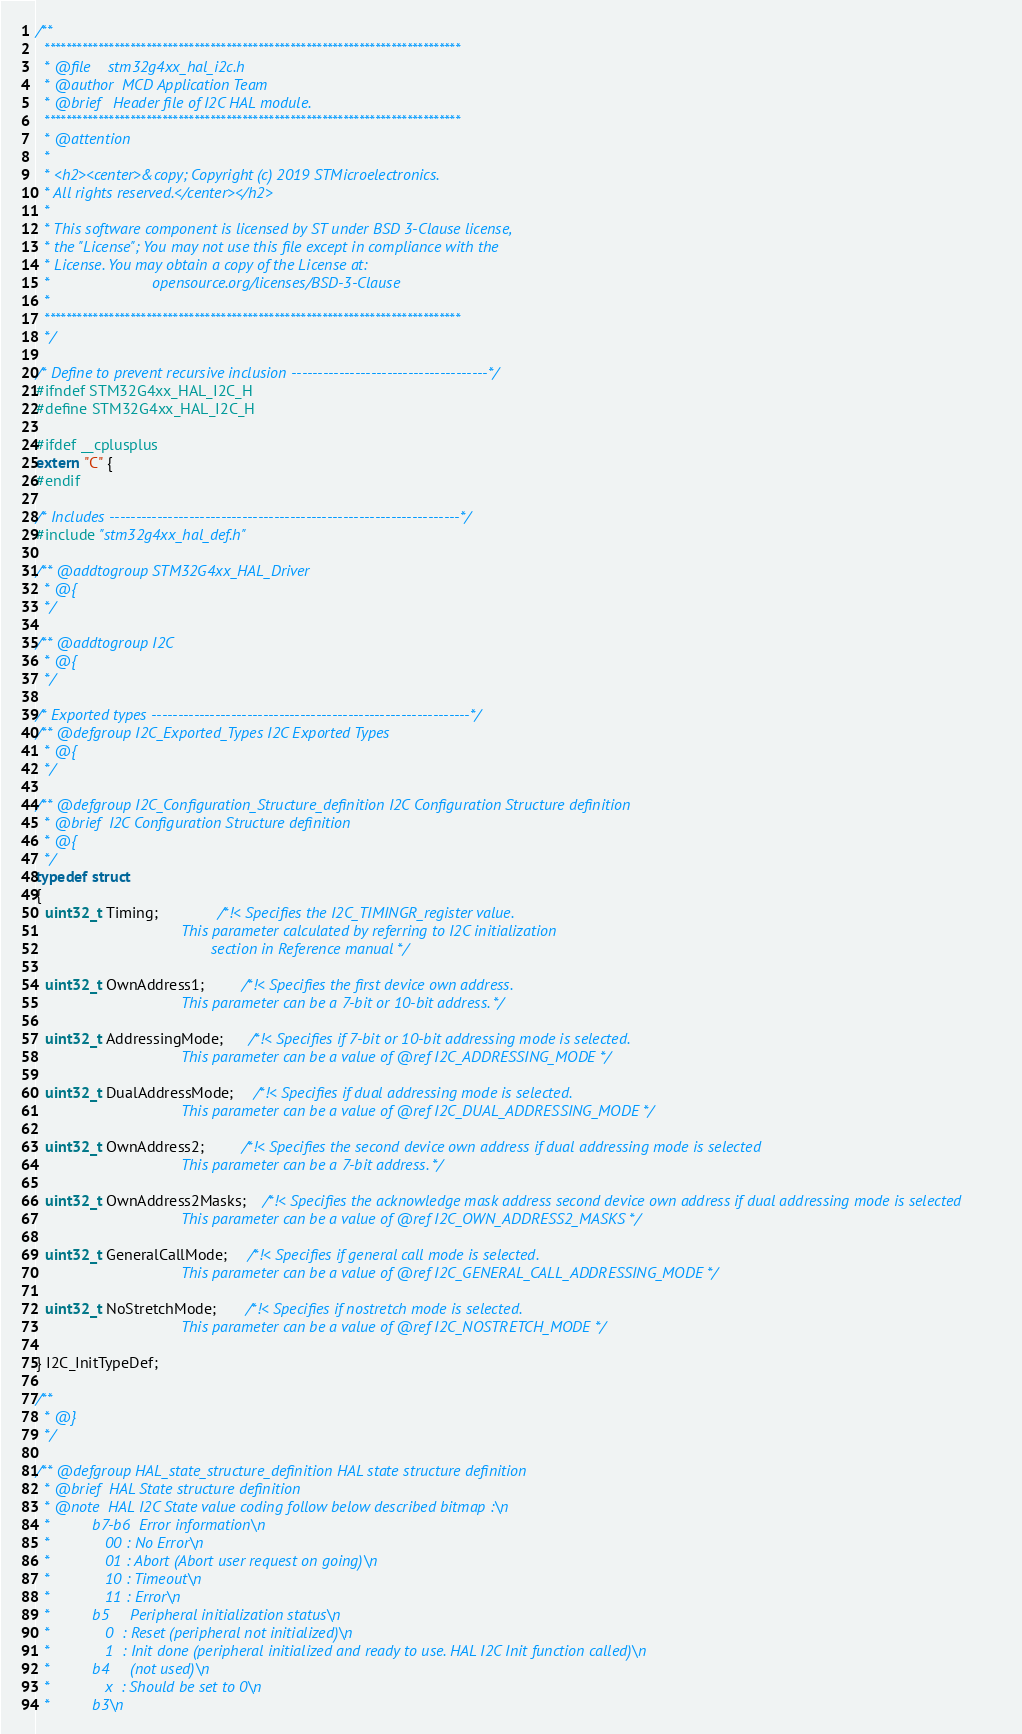<code> <loc_0><loc_0><loc_500><loc_500><_C_>/**
  ******************************************************************************
  * @file    stm32g4xx_hal_i2c.h
  * @author  MCD Application Team
  * @brief   Header file of I2C HAL module.
  ******************************************************************************
  * @attention
  *
  * <h2><center>&copy; Copyright (c) 2019 STMicroelectronics.
  * All rights reserved.</center></h2>
  *
  * This software component is licensed by ST under BSD 3-Clause license,
  * the "License"; You may not use this file except in compliance with the
  * License. You may obtain a copy of the License at:
  *                        opensource.org/licenses/BSD-3-Clause
  *
  ******************************************************************************
  */

/* Define to prevent recursive inclusion -------------------------------------*/
#ifndef STM32G4xx_HAL_I2C_H
#define STM32G4xx_HAL_I2C_H

#ifdef __cplusplus
extern "C" {
#endif

/* Includes ------------------------------------------------------------------*/
#include "stm32g4xx_hal_def.h"

/** @addtogroup STM32G4xx_HAL_Driver
  * @{
  */

/** @addtogroup I2C
  * @{
  */

/* Exported types ------------------------------------------------------------*/
/** @defgroup I2C_Exported_Types I2C Exported Types
  * @{
  */

/** @defgroup I2C_Configuration_Structure_definition I2C Configuration Structure definition
  * @brief  I2C Configuration Structure definition
  * @{
  */
typedef struct
{
  uint32_t Timing;              /*!< Specifies the I2C_TIMINGR_register value.
                                  This parameter calculated by referring to I2C initialization
                                         section in Reference manual */

  uint32_t OwnAddress1;         /*!< Specifies the first device own address.
                                  This parameter can be a 7-bit or 10-bit address. */

  uint32_t AddressingMode;      /*!< Specifies if 7-bit or 10-bit addressing mode is selected.
                                  This parameter can be a value of @ref I2C_ADDRESSING_MODE */

  uint32_t DualAddressMode;     /*!< Specifies if dual addressing mode is selected.
                                  This parameter can be a value of @ref I2C_DUAL_ADDRESSING_MODE */

  uint32_t OwnAddress2;         /*!< Specifies the second device own address if dual addressing mode is selected
                                  This parameter can be a 7-bit address. */

  uint32_t OwnAddress2Masks;    /*!< Specifies the acknowledge mask address second device own address if dual addressing mode is selected
                                  This parameter can be a value of @ref I2C_OWN_ADDRESS2_MASKS */

  uint32_t GeneralCallMode;     /*!< Specifies if general call mode is selected.
                                  This parameter can be a value of @ref I2C_GENERAL_CALL_ADDRESSING_MODE */

  uint32_t NoStretchMode;       /*!< Specifies if nostretch mode is selected.
                                  This parameter can be a value of @ref I2C_NOSTRETCH_MODE */

} I2C_InitTypeDef;

/**
  * @}
  */

/** @defgroup HAL_state_structure_definition HAL state structure definition
  * @brief  HAL State structure definition
  * @note  HAL I2C State value coding follow below described bitmap :\n
  *          b7-b6  Error information\n
  *             00 : No Error\n
  *             01 : Abort (Abort user request on going)\n
  *             10 : Timeout\n
  *             11 : Error\n
  *          b5     Peripheral initialization status\n
  *             0  : Reset (peripheral not initialized)\n
  *             1  : Init done (peripheral initialized and ready to use. HAL I2C Init function called)\n
  *          b4     (not used)\n
  *             x  : Should be set to 0\n
  *          b3\n</code> 